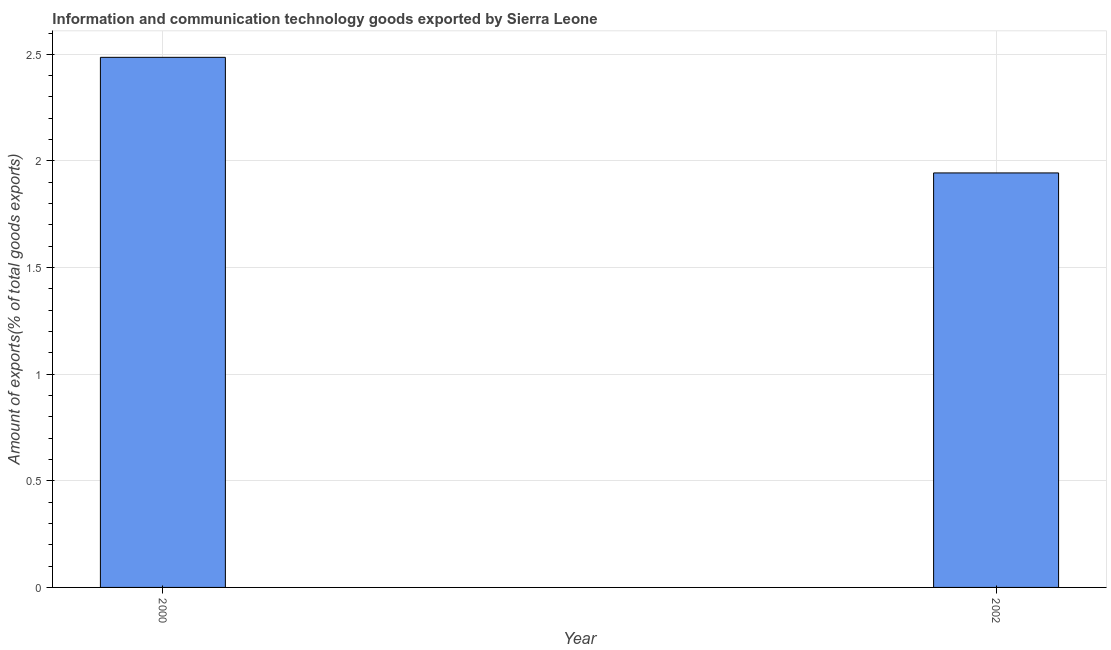Does the graph contain grids?
Your answer should be very brief. Yes. What is the title of the graph?
Your response must be concise. Information and communication technology goods exported by Sierra Leone. What is the label or title of the X-axis?
Offer a terse response. Year. What is the label or title of the Y-axis?
Provide a succinct answer. Amount of exports(% of total goods exports). What is the amount of ict goods exports in 2000?
Offer a very short reply. 2.49. Across all years, what is the maximum amount of ict goods exports?
Your answer should be very brief. 2.49. Across all years, what is the minimum amount of ict goods exports?
Your answer should be compact. 1.94. In which year was the amount of ict goods exports minimum?
Provide a succinct answer. 2002. What is the sum of the amount of ict goods exports?
Make the answer very short. 4.43. What is the difference between the amount of ict goods exports in 2000 and 2002?
Ensure brevity in your answer.  0.54. What is the average amount of ict goods exports per year?
Keep it short and to the point. 2.21. What is the median amount of ict goods exports?
Offer a terse response. 2.21. What is the ratio of the amount of ict goods exports in 2000 to that in 2002?
Your answer should be very brief. 1.28. In how many years, is the amount of ict goods exports greater than the average amount of ict goods exports taken over all years?
Your response must be concise. 1. How many years are there in the graph?
Offer a terse response. 2. What is the difference between two consecutive major ticks on the Y-axis?
Your answer should be very brief. 0.5. Are the values on the major ticks of Y-axis written in scientific E-notation?
Offer a terse response. No. What is the Amount of exports(% of total goods exports) in 2000?
Make the answer very short. 2.49. What is the Amount of exports(% of total goods exports) of 2002?
Offer a very short reply. 1.94. What is the difference between the Amount of exports(% of total goods exports) in 2000 and 2002?
Your answer should be compact. 0.54. What is the ratio of the Amount of exports(% of total goods exports) in 2000 to that in 2002?
Provide a short and direct response. 1.28. 